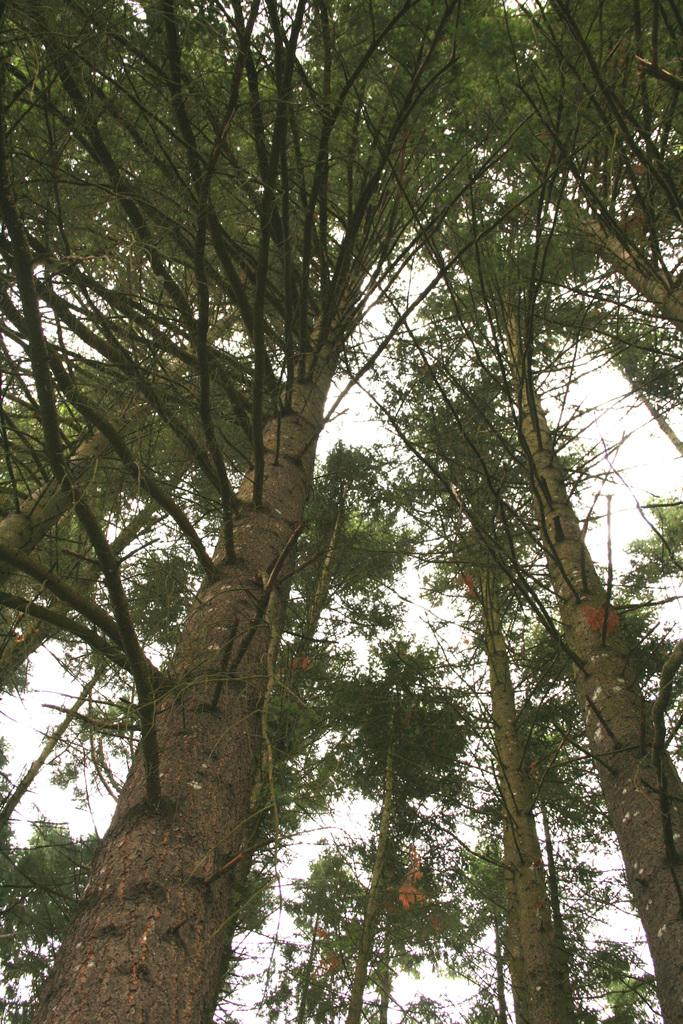What type of vegetation can be seen in the image? There are trees in the image. How many firemen are climbing the trees in the image? There are no firemen present in the image, as it only features trees. What type of currency can be seen on the branches of the trees in the image? There is no currency visible on the branches of the trees in the image. 